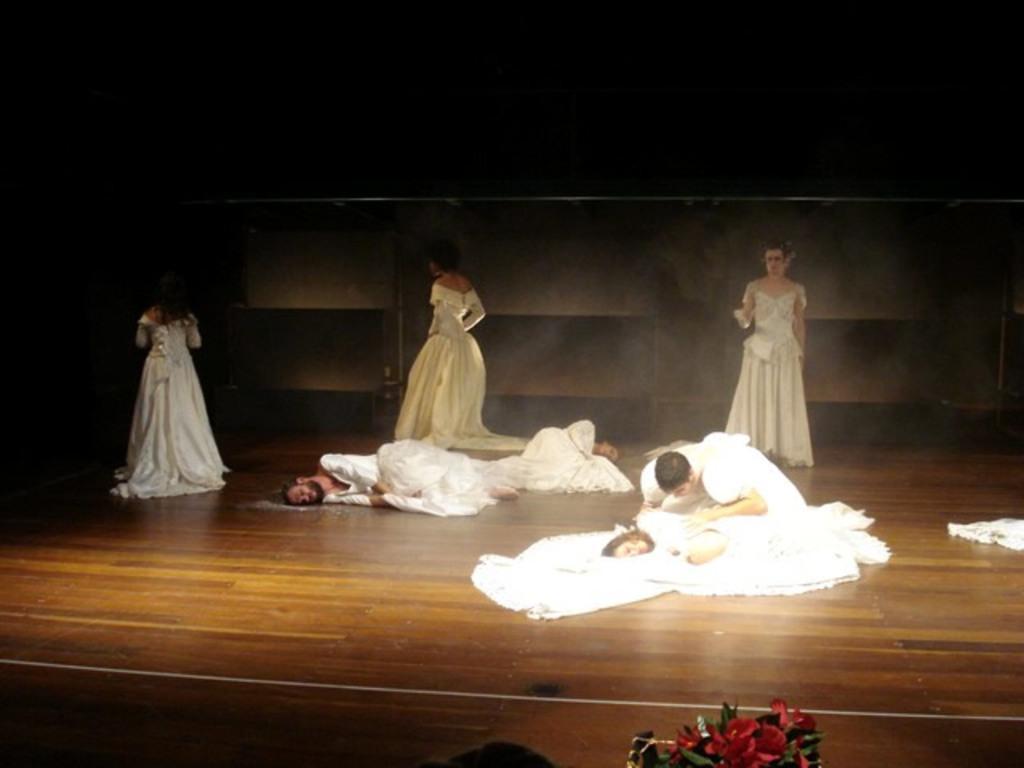How would you summarize this image in a sentence or two? There are three persons in white color dresses laying on a stage. A person is kneeling down and slightly bending on a stage. And three persons are standing on the stage. In front of them, there is a flower vase. And the background is dark in color. 